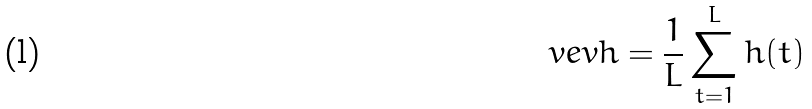Convert formula to latex. <formula><loc_0><loc_0><loc_500><loc_500>\ v e v { h } = \frac { 1 } { L } \sum _ { t = 1 } ^ { L } h ( t )</formula> 